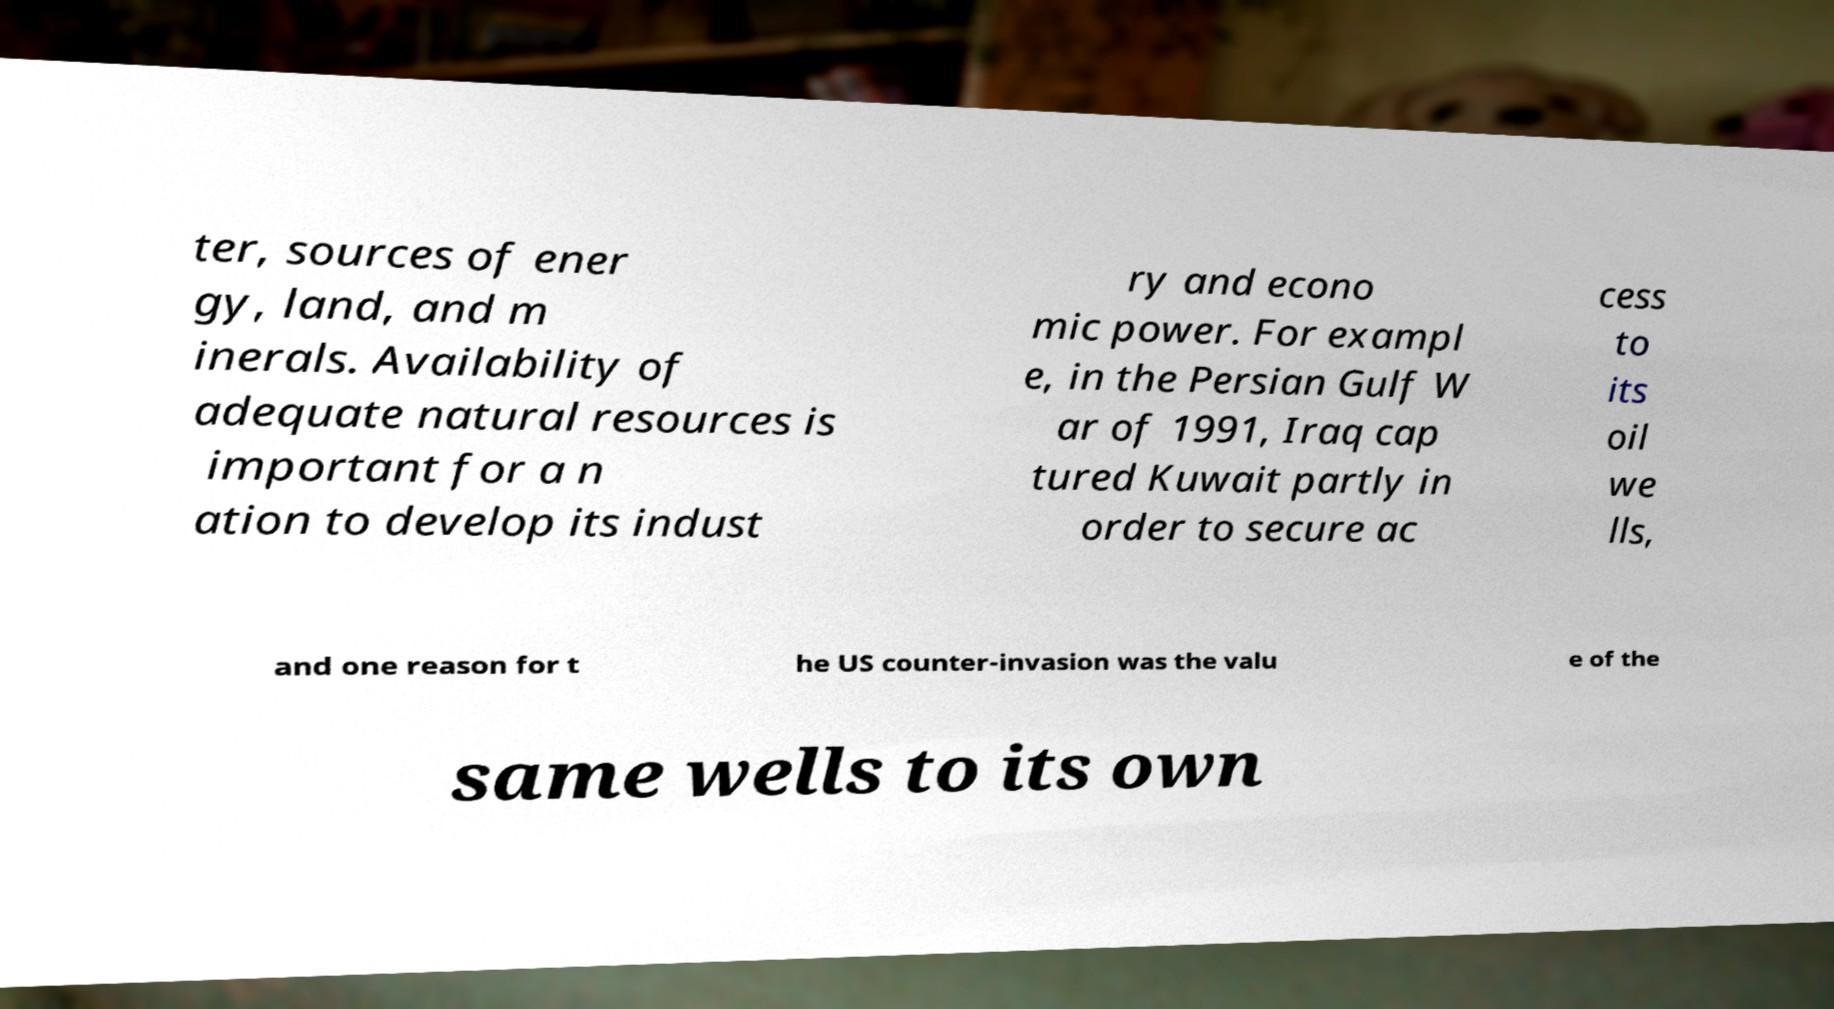Could you extract and type out the text from this image? ter, sources of ener gy, land, and m inerals. Availability of adequate natural resources is important for a n ation to develop its indust ry and econo mic power. For exampl e, in the Persian Gulf W ar of 1991, Iraq cap tured Kuwait partly in order to secure ac cess to its oil we lls, and one reason for t he US counter-invasion was the valu e of the same wells to its own 